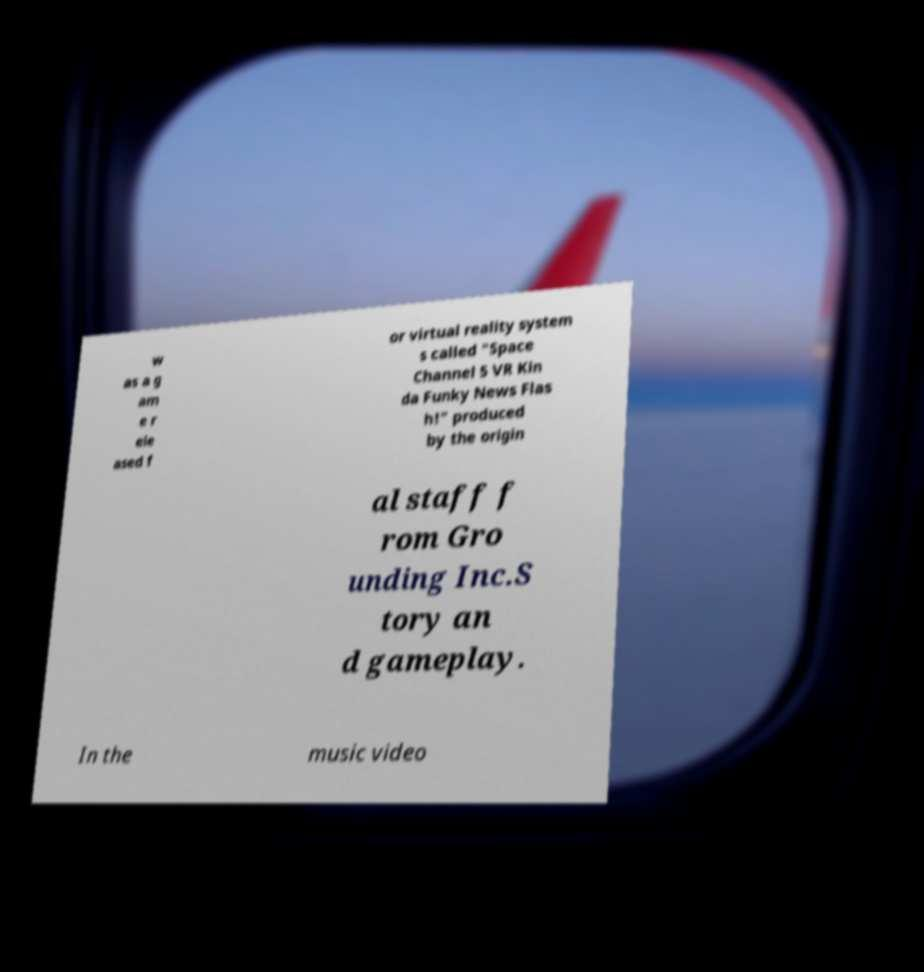I need the written content from this picture converted into text. Can you do that? w as a g am e r ele ased f or virtual reality system s called "Space Channel 5 VR Kin da Funky News Flas h!" produced by the origin al staff f rom Gro unding Inc.S tory an d gameplay. In the music video 